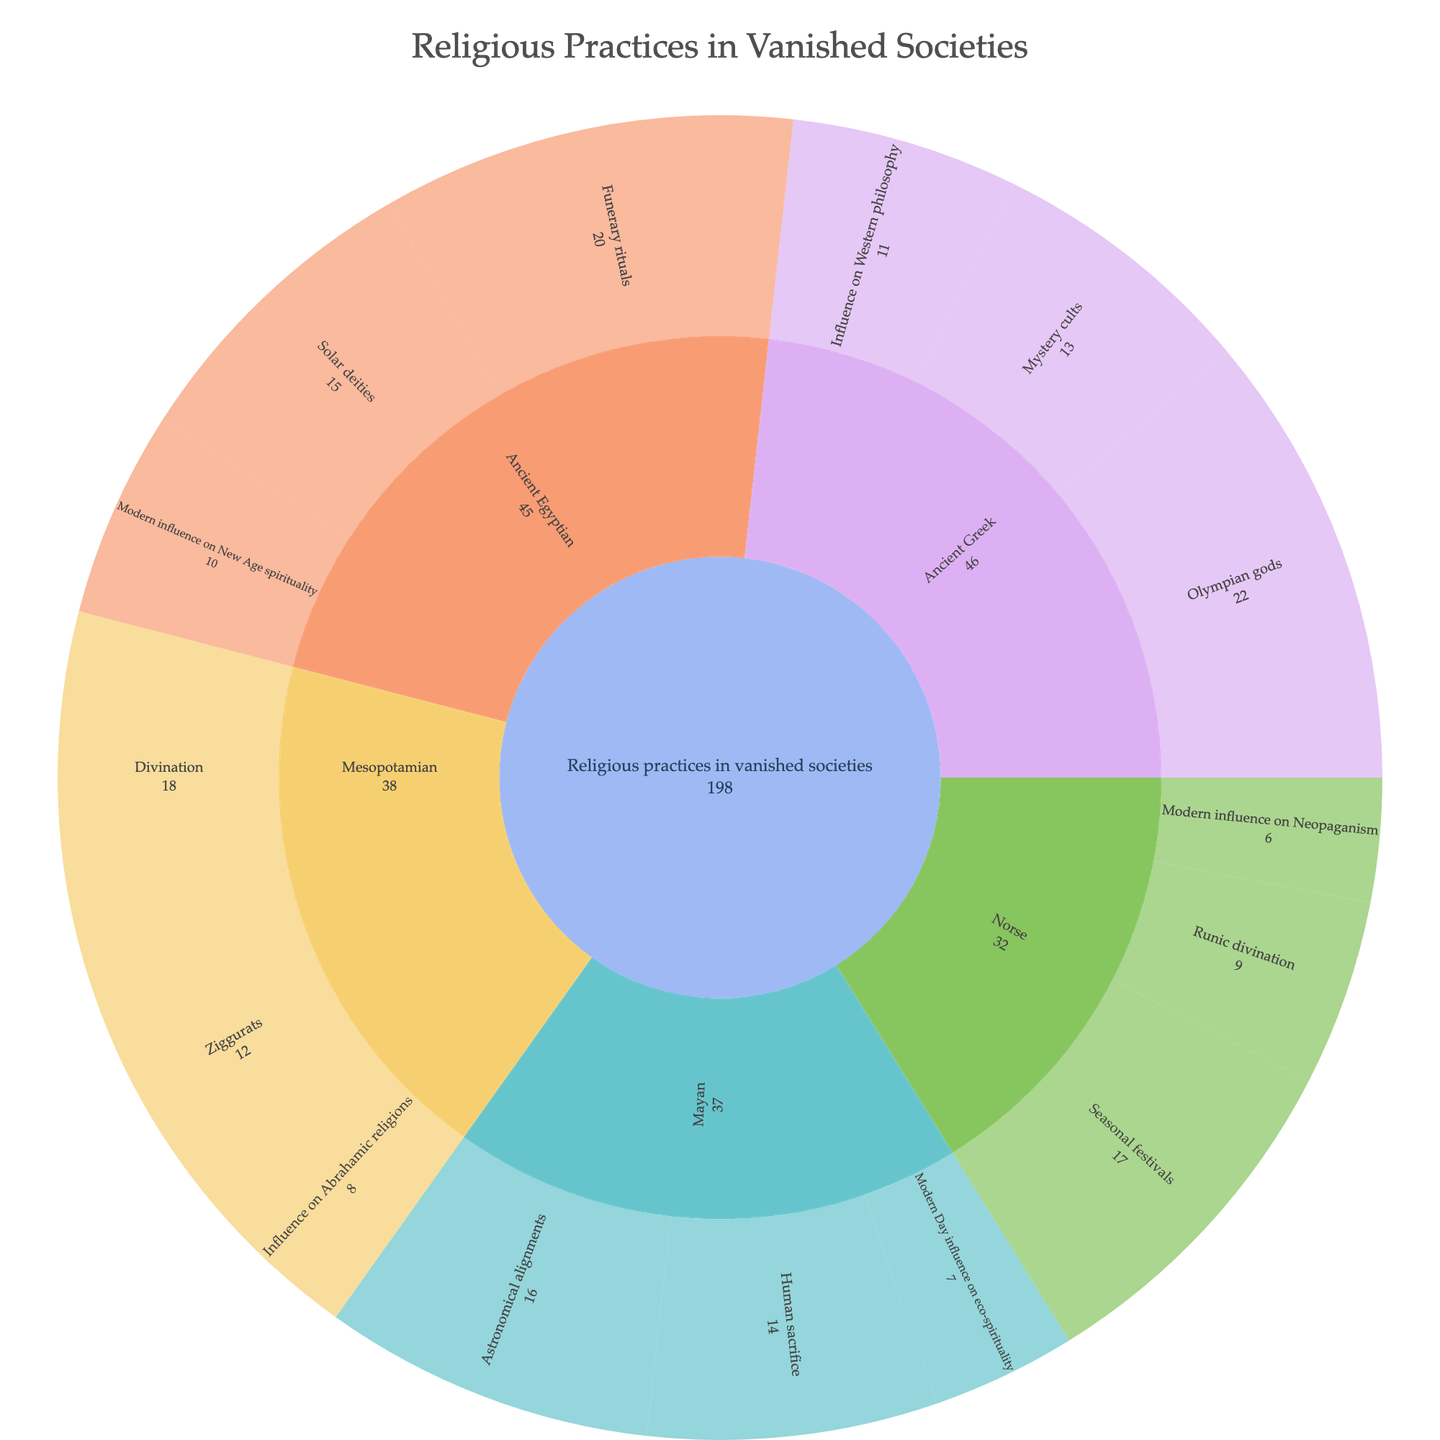Who has the highest number of rituals mentioned in the plot? The "Ancient Greek" category has the highest number with a total of 22 for Olympian gods, 13 for Mystery cults, and 11 for Influence on Western philosophy.
Answer: Ancient Greek How many categories of Mayan religious practices are depicted? The Mayan religious practices are divided into three categories: Human sacrifice, Astronomical alignments, and Modern Day influence on eco-spirituality.
Answer: Three Which religious practice within the Ancient Egyptian category has the highest value? Within the Ancient Egyptian category, Funerary rituals have the highest value, which is 20.
Answer: Funerary rituals Compare the number of rituals under Ancient Greek and Mayan categories. Which one has more? Ancient Greek has a total of 46 (22 + 13 + 11), while Mayan has a total of 37 (14 + 16 + 7). Therefore, Ancient Greek has more rituals depicted.
Answer: Ancient Greek What is the sum of all modern influences mentioned in the plot? The modern influences include: Ancient Egyptian (10), Mesopotamian (8), Mayan (7), and Norse (6). Summing them up, (10 + 8 + 7 + 6) = 31.
Answer: 31 How does the value of Mayan Human sacrifice compare to Norse Seasonal festivals? The value of Mayan Human sacrifice is 14, whereas Norse Seasonal festivals have a value of 17. Therefore, Norse Seasonal festivals have a higher value.
Answer: Norse Seasonal festivals What is the total value of Mesopotamian religious practices? Adding the values for Mesopotamian Ziggurats (12), Divination (18), and Influence on Abrahamic religions (8), the total is 12 + 18 + 8 = 38.
Answer: 38 Identify the category with the least mentioned practice and specify the practice. The Norse category has the practice ‘Modern influence on Neopaganism’ with the value of 6, which is the least mentioned practice.
Answer: Norse, Modern influence on Neopaganism 